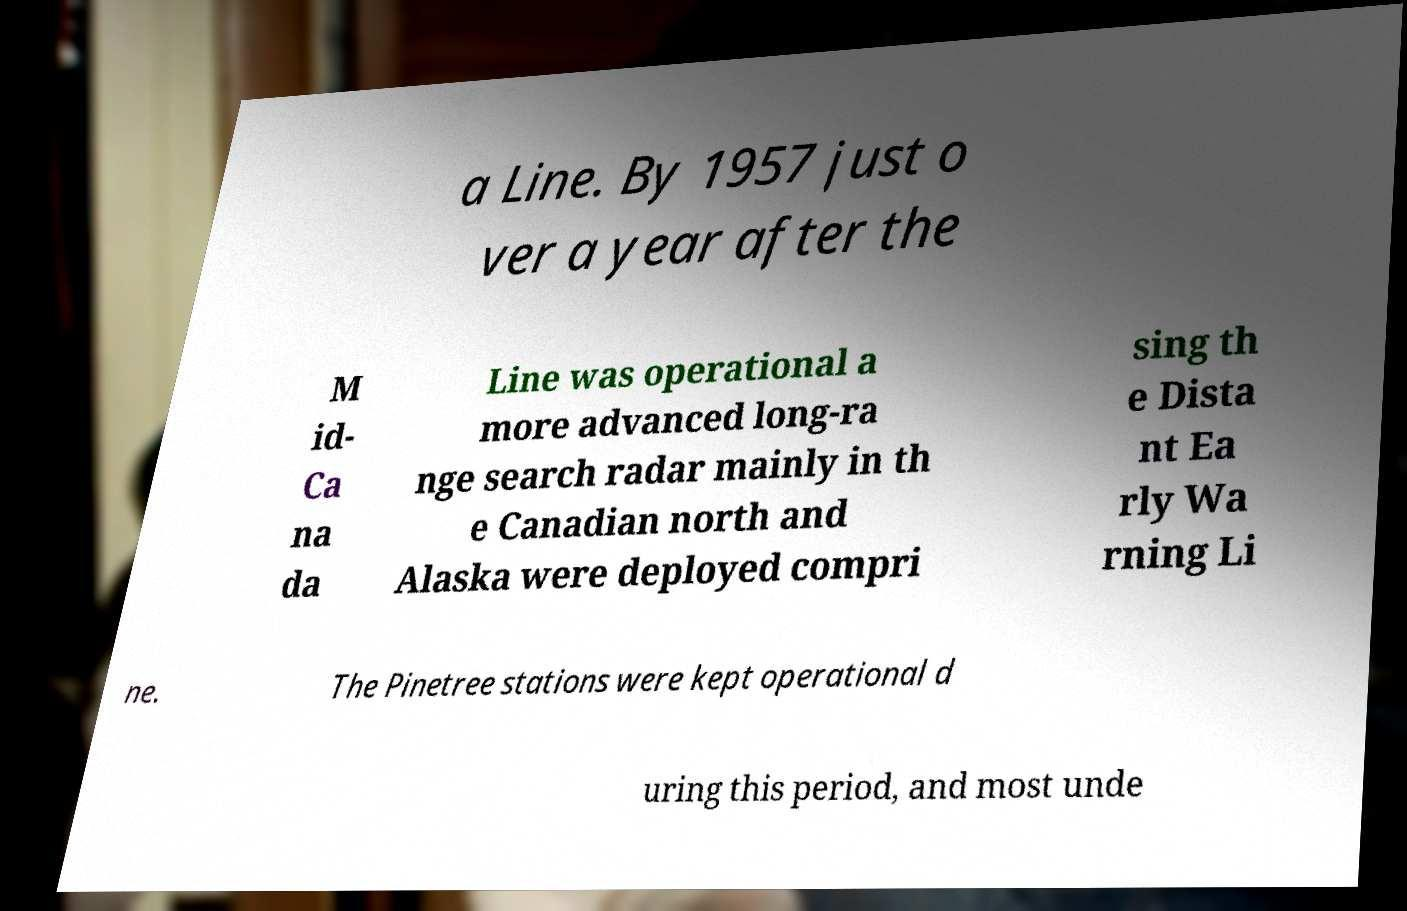Please identify and transcribe the text found in this image. a Line. By 1957 just o ver a year after the M id- Ca na da Line was operational a more advanced long-ra nge search radar mainly in th e Canadian north and Alaska were deployed compri sing th e Dista nt Ea rly Wa rning Li ne. The Pinetree stations were kept operational d uring this period, and most unde 